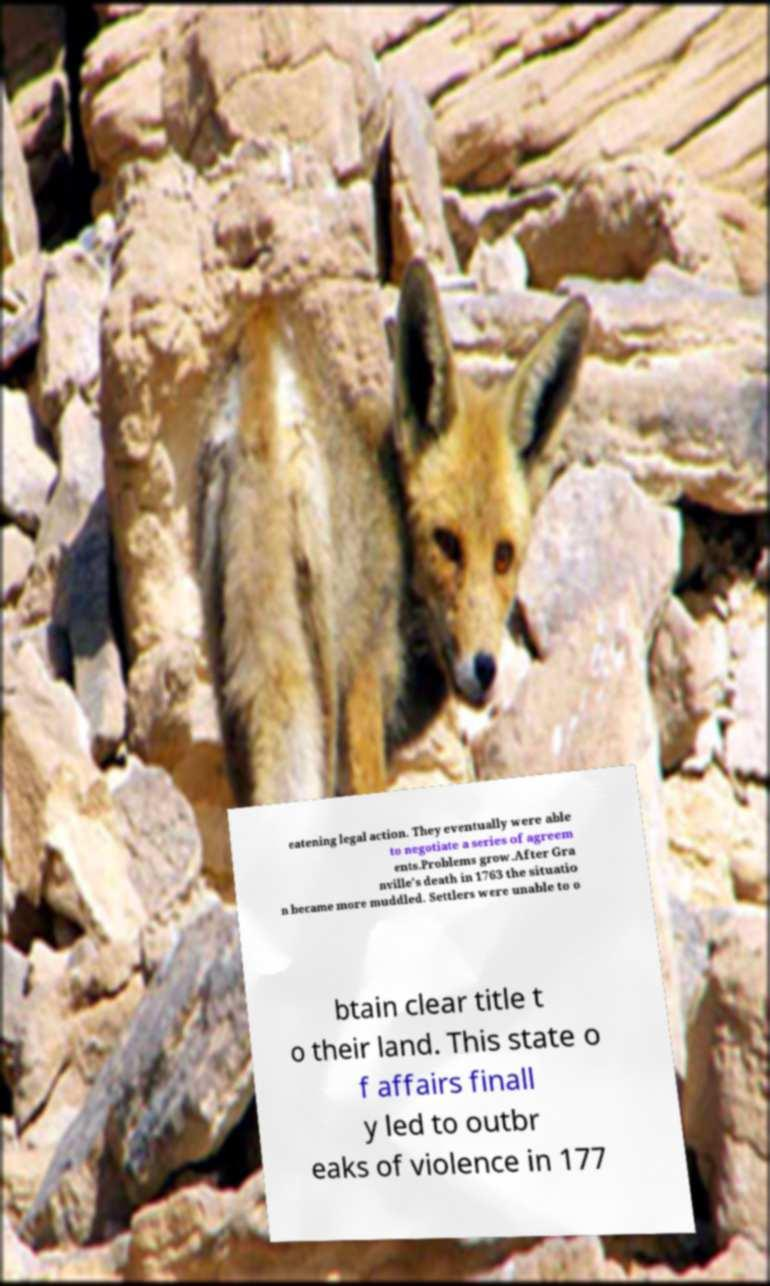Can you accurately transcribe the text from the provided image for me? eatening legal action. They eventually were able to negotiate a series of agreem ents.Problems grow.After Gra nville's death in 1763 the situatio n became more muddled. Settlers were unable to o btain clear title t o their land. This state o f affairs finall y led to outbr eaks of violence in 177 